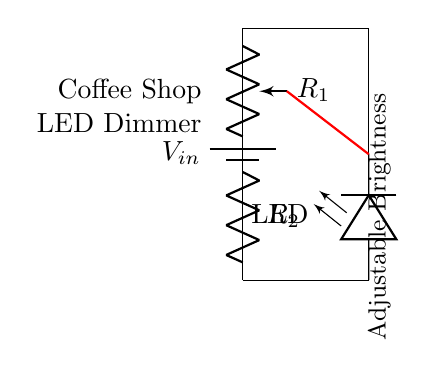What is the input voltage in the circuit? The input voltage is labeled as V_in, which represents the voltage supplied to the circuit.
Answer: V_in What type of components are used to adjust the brightness of the LED? The circuit uses a potentiometer (R_1) and a resistor (R_2) as voltage divider components to adjust the brightness.
Answer: Potentiometer and Resistor How many components are there in total in the circuit? The circuit consists of four components: one battery, one potentiometer, one resistor, and one LED. By counting these components, we arrive at the total number.
Answer: Four What is the purpose of the wiper in the circuit? The wiper, which is a part of the potentiometer, allows the user to adjust the resistance and thereby vary the voltage across the LED, controlling its brightness.
Answer: Adjustable brightness How do R_1 and R_2 affect the brightness of the LED? R_1 and R_2 form a voltage divider, where the combined resistance influences the voltage drop across the LED. The more resistance, the less voltage, resulting in dimmer brightness.
Answer: They form a voltage divider What is the overall function of this circuit? The circuit functions as a dimmer for LED lighting, allowing adjustment of brightness through varying voltage levels obtained by the voltage divider.
Answer: LED dimming 